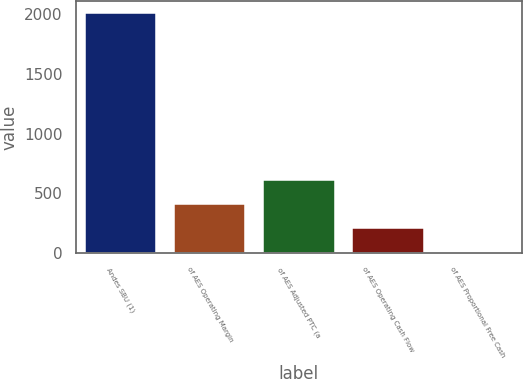Convert chart. <chart><loc_0><loc_0><loc_500><loc_500><bar_chart><fcel>Andes SBU (1)<fcel>of AES Operating Margin<fcel>of AES Adjusted PTC (a<fcel>of AES Operating Cash Flow<fcel>of AES Proportional Free Cash<nl><fcel>2014<fcel>413.2<fcel>613.3<fcel>213.1<fcel>13<nl></chart> 